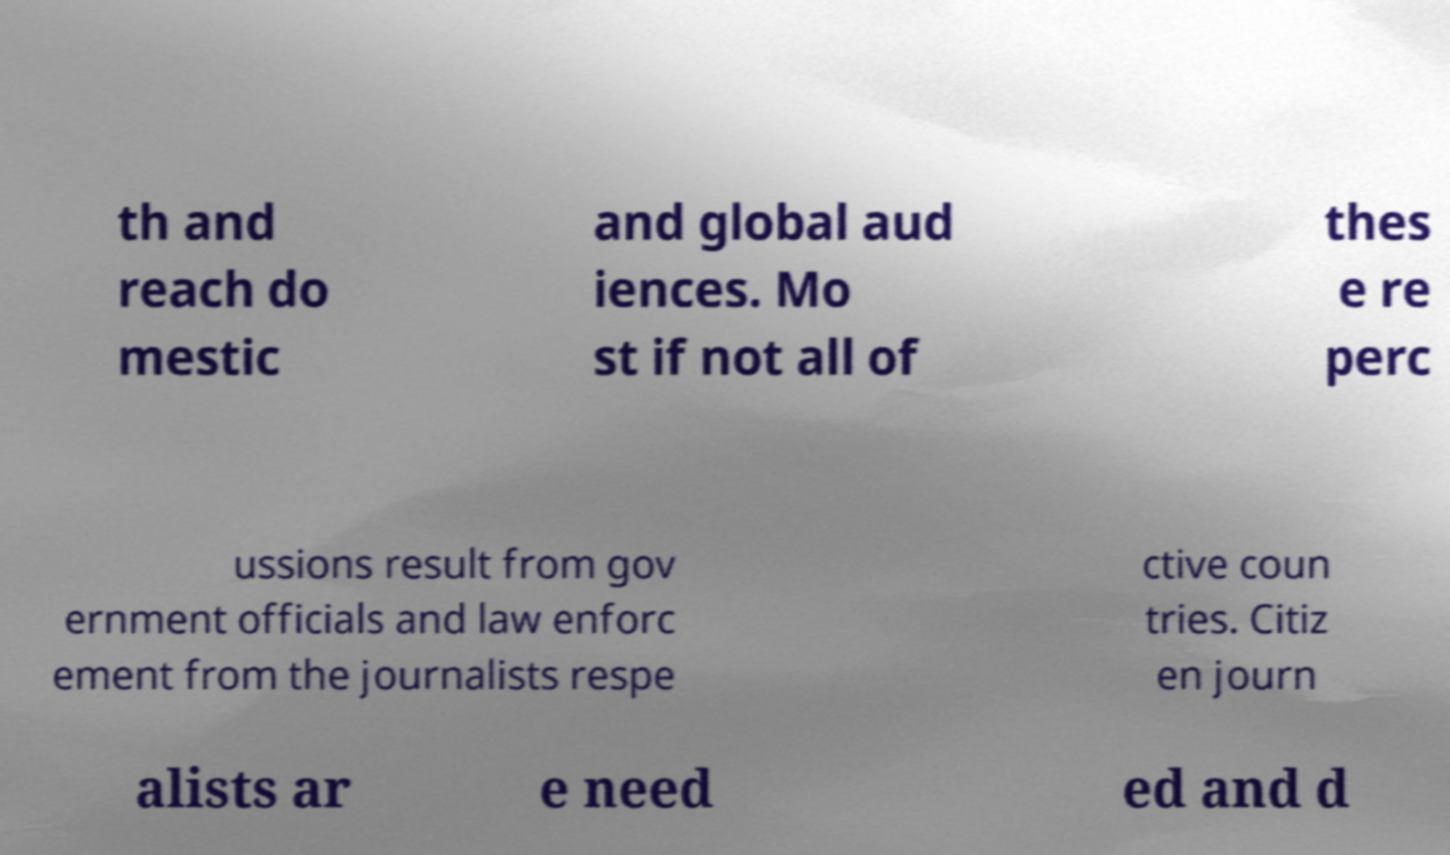What messages or text are displayed in this image? I need them in a readable, typed format. th and reach do mestic and global aud iences. Mo st if not all of thes e re perc ussions result from gov ernment officials and law enforc ement from the journalists respe ctive coun tries. Citiz en journ alists ar e need ed and d 